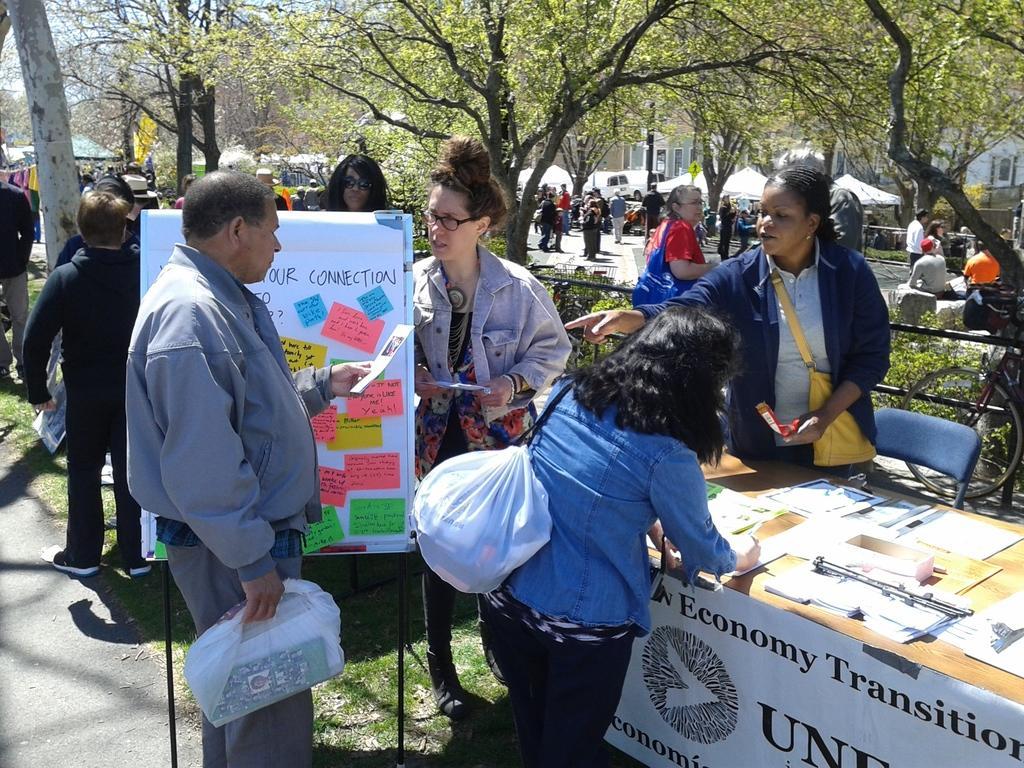Could you give a brief overview of what you see in this image? In this image a person is standing on the road. He is holding a bag with one hand and paper with the other hand. Beside him there is a board having few papers attached to it. Few persons are standing on the grassland. Right side there is a table having few objects on it. A banner is attached to the table. Before the table there is a woman carrying a bag. Behind the table there is a woman carrying a bag. Behind her there is a chair. Right side there is a bicycle. Behind the fence there are few plants and trees. Few persons are on the road. There are few tents on the grassland. Background there are few buildings and trees. 